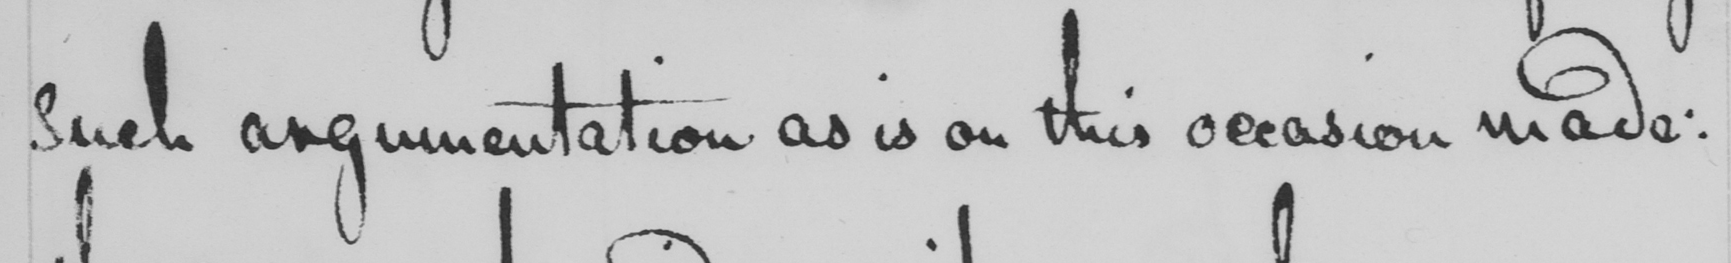What is written in this line of handwriting? such argumentation as is on this occasion made : 